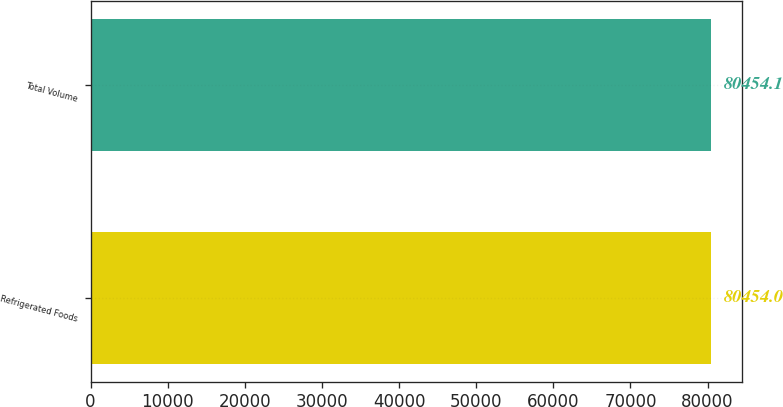<chart> <loc_0><loc_0><loc_500><loc_500><bar_chart><fcel>Refrigerated Foods<fcel>Total Volume<nl><fcel>80454<fcel>80454.1<nl></chart> 